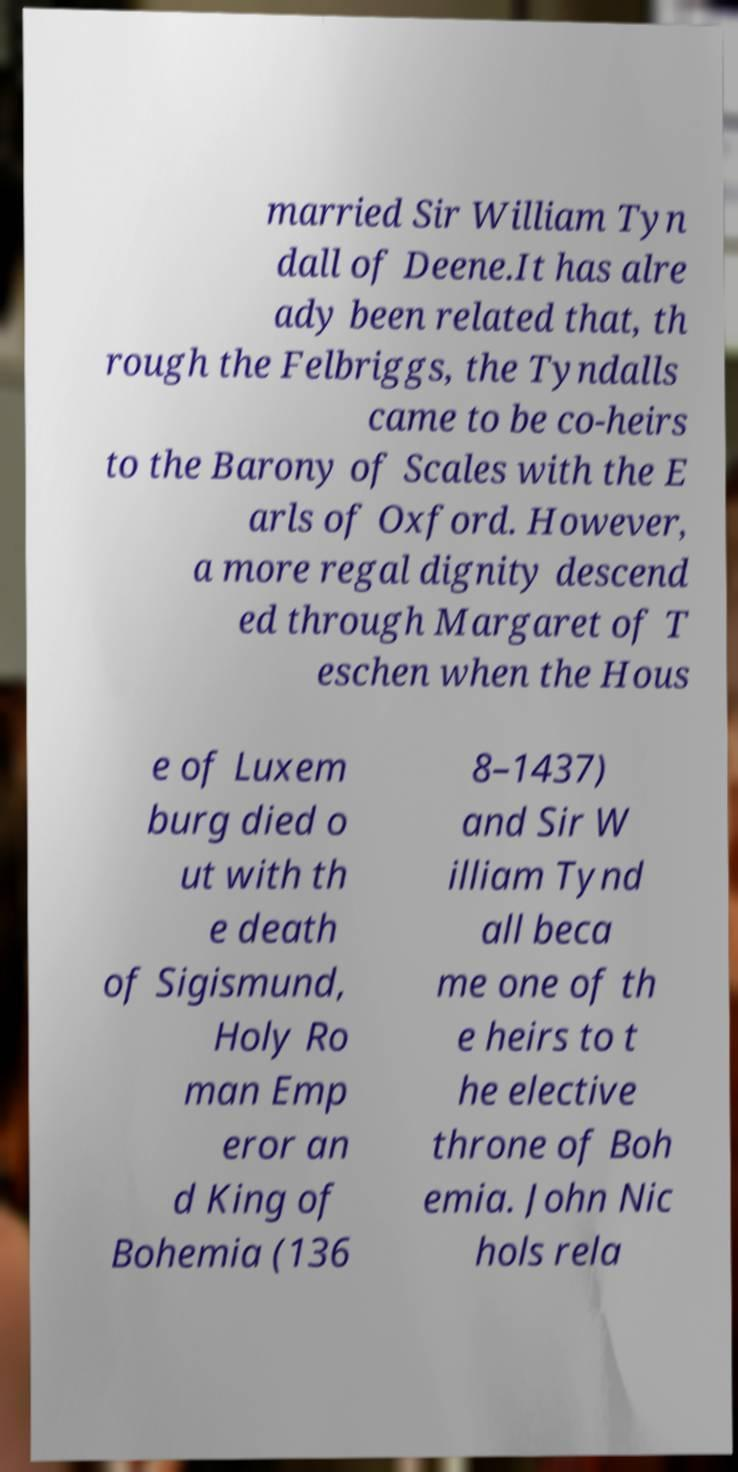Can you accurately transcribe the text from the provided image for me? married Sir William Tyn dall of Deene.It has alre ady been related that, th rough the Felbriggs, the Tyndalls came to be co-heirs to the Barony of Scales with the E arls of Oxford. However, a more regal dignity descend ed through Margaret of T eschen when the Hous e of Luxem burg died o ut with th e death of Sigismund, Holy Ro man Emp eror an d King of Bohemia (136 8–1437) and Sir W illiam Tynd all beca me one of th e heirs to t he elective throne of Boh emia. John Nic hols rela 